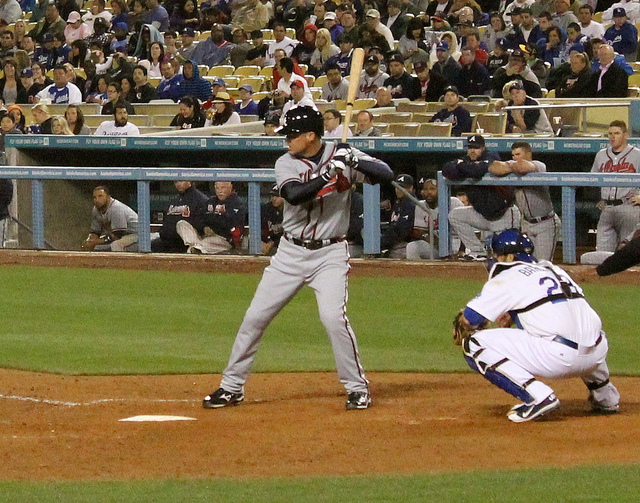<image>Where is the person who is waiting to bat? It is ambiguous where the person waiting to bat is located. They could be in the dugout, left of the battery, between the gate, at the plate, or on the sidelines. Where is the person who is waiting to bat? I don't know where the person who is waiting to bat is. It can be in the dugout, in the box, or anywhere else. 